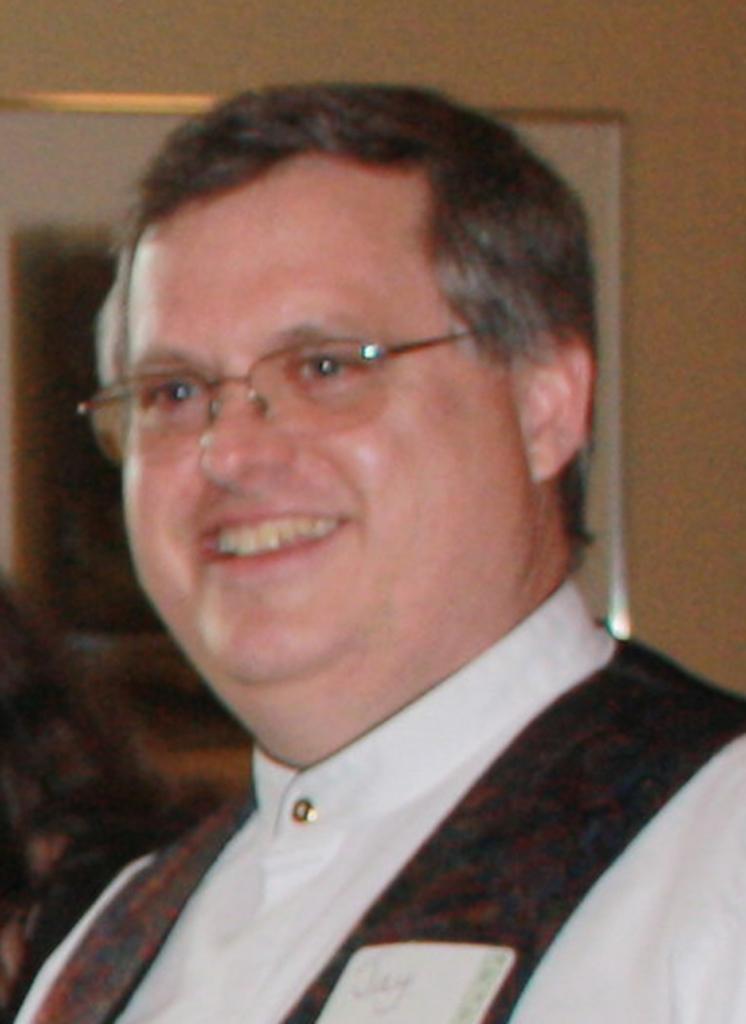In one or two sentences, can you explain what this image depicts? This image is taken indoors. In the background there is a wall with a picture frame. In the middle of the image there is a man with a smiling face. 